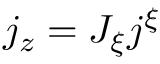Convert formula to latex. <formula><loc_0><loc_0><loc_500><loc_500>j _ { z } = J _ { \xi } j ^ { \xi }</formula> 